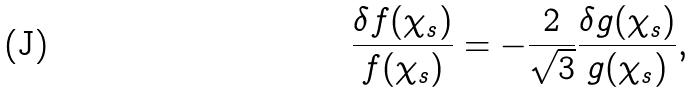<formula> <loc_0><loc_0><loc_500><loc_500>\frac { \delta f ( \chi _ { s } ) } { f ( \chi _ { s } ) } = - \frac { 2 } { \sqrt { 3 } } \frac { \delta g ( \chi _ { s } ) } { g ( \chi _ { s } ) } ,</formula> 